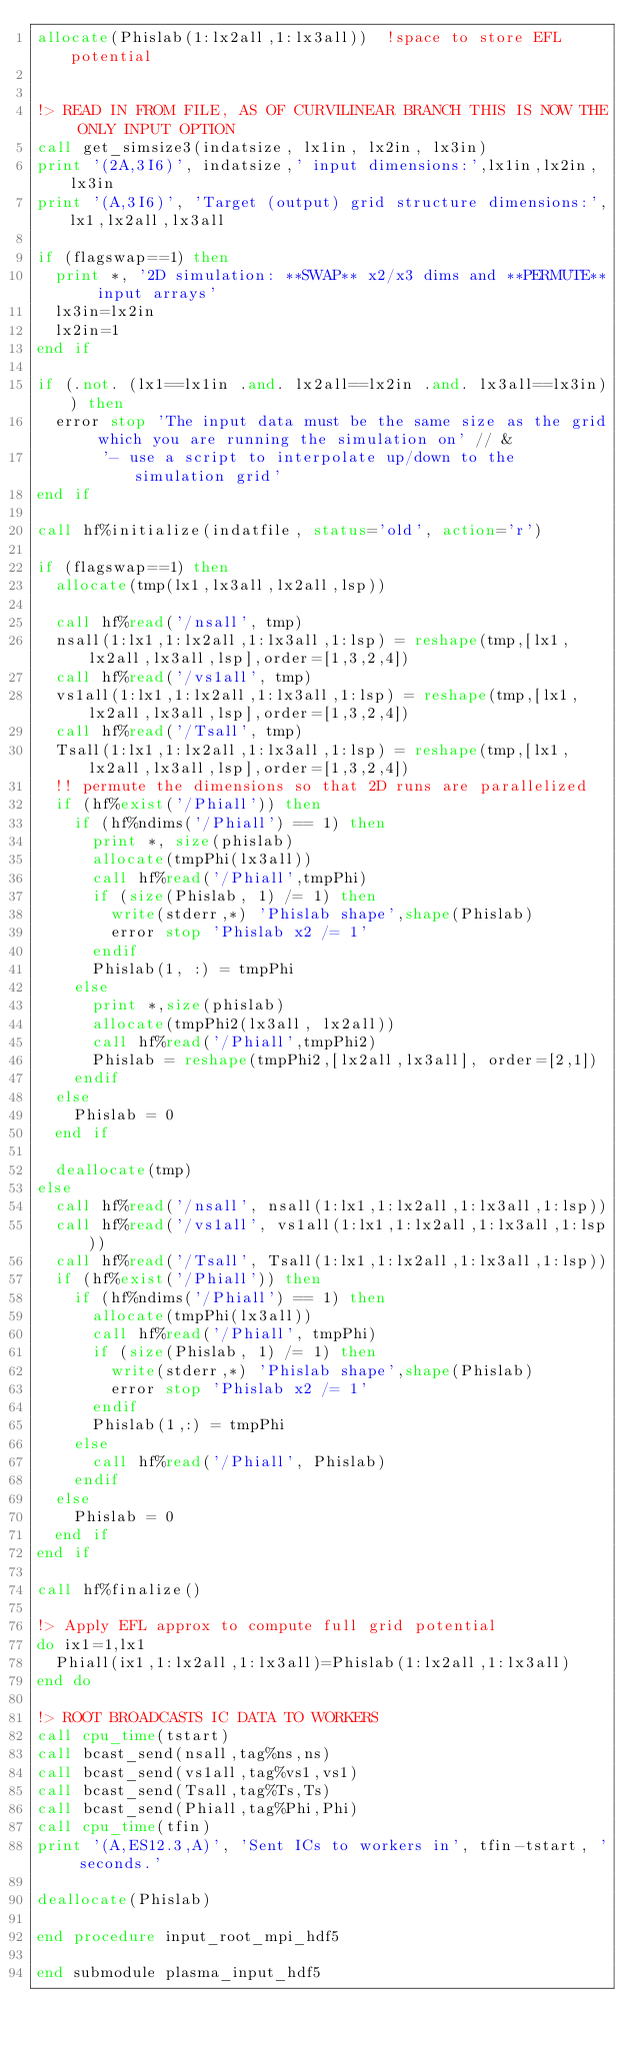<code> <loc_0><loc_0><loc_500><loc_500><_FORTRAN_>allocate(Phislab(1:lx2all,1:lx3all))  !space to store EFL potential


!> READ IN FROM FILE, AS OF CURVILINEAR BRANCH THIS IS NOW THE ONLY INPUT OPTION
call get_simsize3(indatsize, lx1in, lx2in, lx3in)
print '(2A,3I6)', indatsize,' input dimensions:',lx1in,lx2in,lx3in
print '(A,3I6)', 'Target (output) grid structure dimensions:',lx1,lx2all,lx3all

if (flagswap==1) then
  print *, '2D simulation: **SWAP** x2/x3 dims and **PERMUTE** input arrays'
  lx3in=lx2in
  lx2in=1
end if

if (.not. (lx1==lx1in .and. lx2all==lx2in .and. lx3all==lx3in)) then
  error stop 'The input data must be the same size as the grid which you are running the simulation on' // &
       '- use a script to interpolate up/down to the simulation grid'
end if

call hf%initialize(indatfile, status='old', action='r')

if (flagswap==1) then
  allocate(tmp(lx1,lx3all,lx2all,lsp))

  call hf%read('/nsall', tmp)
  nsall(1:lx1,1:lx2all,1:lx3all,1:lsp) = reshape(tmp,[lx1,lx2all,lx3all,lsp],order=[1,3,2,4])
  call hf%read('/vs1all', tmp)
  vs1all(1:lx1,1:lx2all,1:lx3all,1:lsp) = reshape(tmp,[lx1,lx2all,lx3all,lsp],order=[1,3,2,4])
  call hf%read('/Tsall', tmp)
  Tsall(1:lx1,1:lx2all,1:lx3all,1:lsp) = reshape(tmp,[lx1,lx2all,lx3all,lsp],order=[1,3,2,4])
  !! permute the dimensions so that 2D runs are parallelized
  if (hf%exist('/Phiall')) then
    if (hf%ndims('/Phiall') == 1) then
      print *, size(phislab)
      allocate(tmpPhi(lx3all))
      call hf%read('/Phiall',tmpPhi)
      if (size(Phislab, 1) /= 1) then
        write(stderr,*) 'Phislab shape',shape(Phislab)
        error stop 'Phislab x2 /= 1'
      endif
      Phislab(1, :) = tmpPhi
    else
      print *,size(phislab)
      allocate(tmpPhi2(lx3all, lx2all))
      call hf%read('/Phiall',tmpPhi2)
      Phislab = reshape(tmpPhi2,[lx2all,lx3all], order=[2,1])
    endif
  else
    Phislab = 0
  end if

  deallocate(tmp)
else
  call hf%read('/nsall', nsall(1:lx1,1:lx2all,1:lx3all,1:lsp))
  call hf%read('/vs1all', vs1all(1:lx1,1:lx2all,1:lx3all,1:lsp))
  call hf%read('/Tsall', Tsall(1:lx1,1:lx2all,1:lx3all,1:lsp))
  if (hf%exist('/Phiall')) then
    if (hf%ndims('/Phiall') == 1) then
      allocate(tmpPhi(lx3all))
      call hf%read('/Phiall', tmpPhi)
      if (size(Phislab, 1) /= 1) then
        write(stderr,*) 'Phislab shape',shape(Phislab)
        error stop 'Phislab x2 /= 1'
      endif
      Phislab(1,:) = tmpPhi
    else
      call hf%read('/Phiall', Phislab)
    endif
  else
    Phislab = 0
  end if
end if

call hf%finalize()

!> Apply EFL approx to compute full grid potential
do ix1=1,lx1
  Phiall(ix1,1:lx2all,1:lx3all)=Phislab(1:lx2all,1:lx3all)
end do

!> ROOT BROADCASTS IC DATA TO WORKERS
call cpu_time(tstart)
call bcast_send(nsall,tag%ns,ns)
call bcast_send(vs1all,tag%vs1,vs1)
call bcast_send(Tsall,tag%Ts,Ts)
call bcast_send(Phiall,tag%Phi,Phi)
call cpu_time(tfin)
print '(A,ES12.3,A)', 'Sent ICs to workers in', tfin-tstart, ' seconds.'

deallocate(Phislab)

end procedure input_root_mpi_hdf5

end submodule plasma_input_hdf5
</code> 